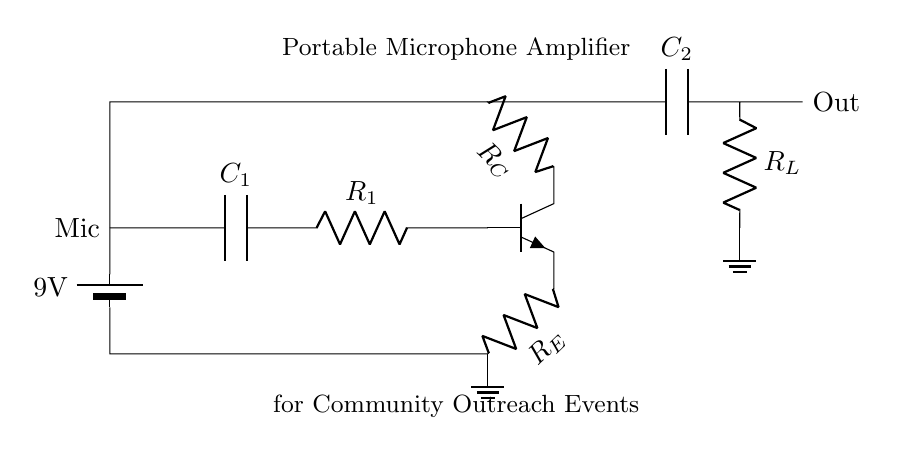What is the power supply voltage for this circuit? The circuit diagram indicates a battery labeled as 9V, which provides the necessary power supply voltage for the amplifier.
Answer: 9 volts What type of components are R1 and RL? Both R1 and RL are resistors indicated by the label R in the circuit diagram, confirming their function as resistive components in the amplifier circuit.
Answer: Resistors How many capacitors are present in the circuit? The circuit diagram shows two capacitors, labeled as C1 and C2, indicating their roles in coupling and decoupling signals in the amplifier.
Answer: Two What is the purpose of the transistor Q1 in this circuit? The transistor Q1 is functioning as an amplifier, using the current from the input to control a larger current at the output, which is fundamental for increasing audio signals from the microphone.
Answer: Amplification What is the role of the resistor RE in the circuit? RE serves as the emitter resistor, which helps stabilize the transistor's operating point and improves linearity in amplification by providing feedback.
Answer: Stabilization What is the output connection labeled as? The output connection is labeled as 'Out', which indicates where the amplified signal exits the circuit to be sent to a speaker or recording device.
Answer: Out How does capacitor C2 affect the audio signal? Capacitor C2 acts as a coupling capacitor, allowing AC signals (audio) to pass while blocking DC offset, which is important for preserving sound quality in the signal output.
Answer: Coupling 